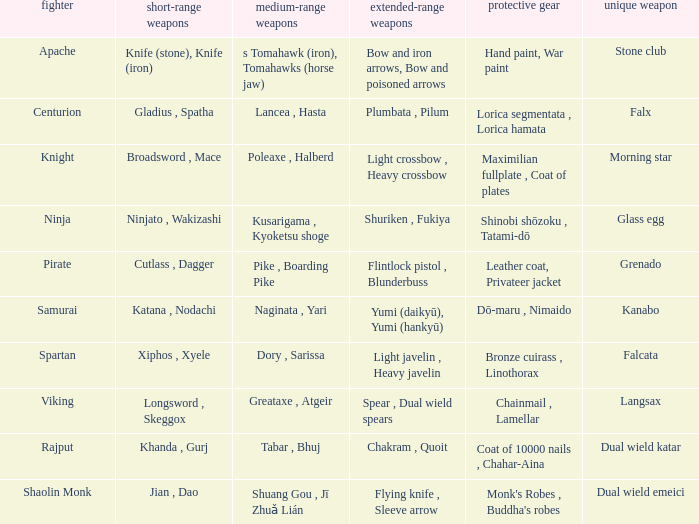If the Close ranged weapons are the knife (stone), knife (iron), what are the Long ranged weapons? Bow and iron arrows, Bow and poisoned arrows. 